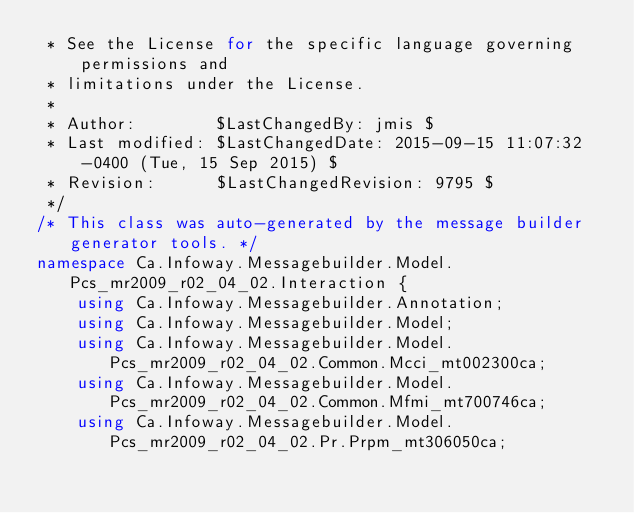Convert code to text. <code><loc_0><loc_0><loc_500><loc_500><_C#_> * See the License for the specific language governing permissions and
 * limitations under the License.
 *
 * Author:        $LastChangedBy: jmis $
 * Last modified: $LastChangedDate: 2015-09-15 11:07:32 -0400 (Tue, 15 Sep 2015) $
 * Revision:      $LastChangedRevision: 9795 $
 */
/* This class was auto-generated by the message builder generator tools. */
namespace Ca.Infoway.Messagebuilder.Model.Pcs_mr2009_r02_04_02.Interaction {
    using Ca.Infoway.Messagebuilder.Annotation;
    using Ca.Infoway.Messagebuilder.Model;
    using Ca.Infoway.Messagebuilder.Model.Pcs_mr2009_r02_04_02.Common.Mcci_mt002300ca;
    using Ca.Infoway.Messagebuilder.Model.Pcs_mr2009_r02_04_02.Common.Mfmi_mt700746ca;
    using Ca.Infoway.Messagebuilder.Model.Pcs_mr2009_r02_04_02.Pr.Prpm_mt306050ca;</code> 